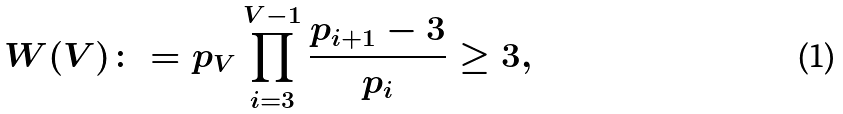Convert formula to latex. <formula><loc_0><loc_0><loc_500><loc_500>W ( V ) \colon = p _ { V } \prod _ { i = 3 } ^ { V - 1 } \frac { p _ { i + 1 } - 3 } { p _ { i } } \geq 3 ,</formula> 